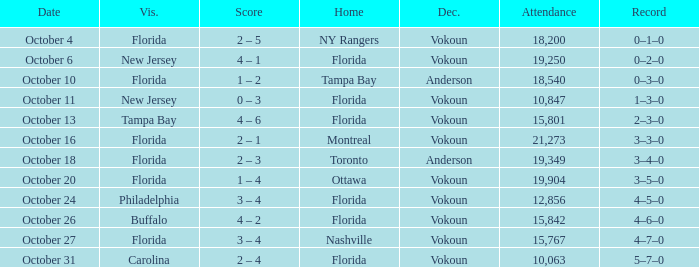Which team won when the visitor was Carolina? Vokoun. 